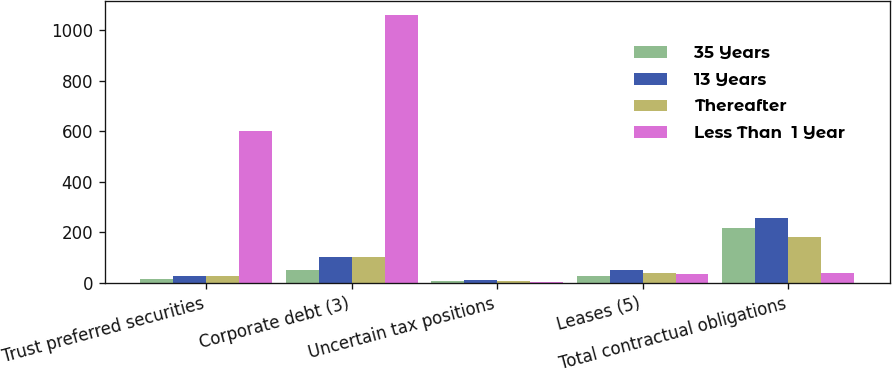Convert chart to OTSL. <chart><loc_0><loc_0><loc_500><loc_500><stacked_bar_chart><ecel><fcel>Trust preferred securities<fcel>Corporate debt (3)<fcel>Uncertain tax positions<fcel>Leases (5)<fcel>Total contractual obligations<nl><fcel>35 Years<fcel>15<fcel>50<fcel>7<fcel>27<fcel>218<nl><fcel>13 Years<fcel>29<fcel>104<fcel>10<fcel>53<fcel>258<nl><fcel>Thereafter<fcel>29<fcel>101<fcel>6<fcel>39<fcel>182<nl><fcel>Less Than  1 Year<fcel>601<fcel>1062<fcel>5<fcel>37<fcel>39<nl></chart> 